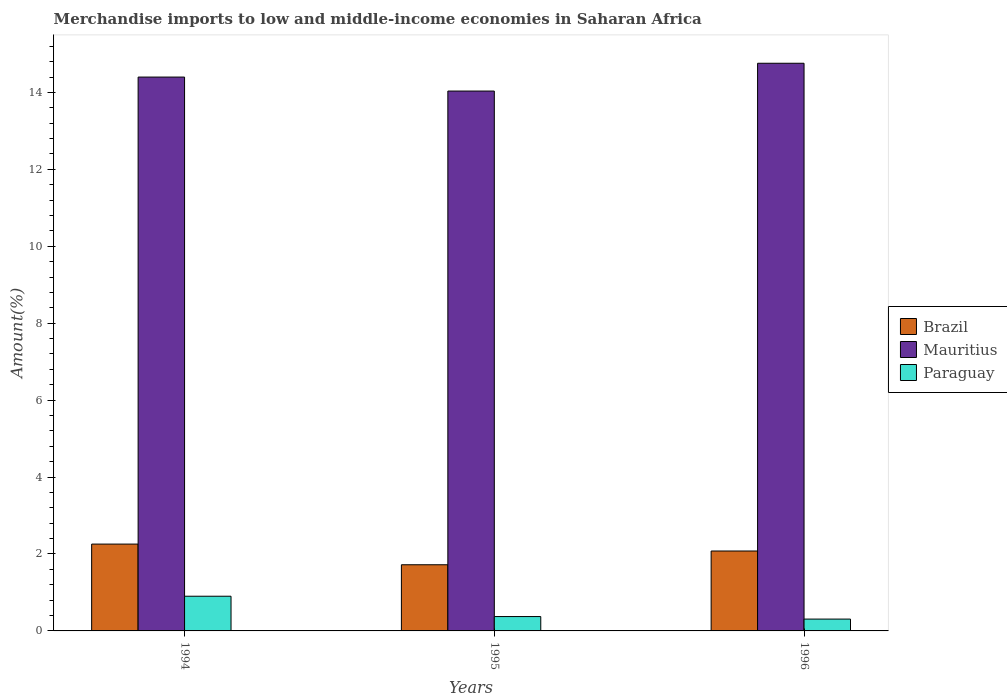Are the number of bars per tick equal to the number of legend labels?
Offer a terse response. Yes. Are the number of bars on each tick of the X-axis equal?
Keep it short and to the point. Yes. How many bars are there on the 1st tick from the left?
Your response must be concise. 3. How many bars are there on the 1st tick from the right?
Provide a short and direct response. 3. In how many cases, is the number of bars for a given year not equal to the number of legend labels?
Your response must be concise. 0. What is the percentage of amount earned from merchandise imports in Paraguay in 1994?
Provide a short and direct response. 0.9. Across all years, what is the maximum percentage of amount earned from merchandise imports in Brazil?
Provide a short and direct response. 2.26. Across all years, what is the minimum percentage of amount earned from merchandise imports in Brazil?
Offer a very short reply. 1.72. What is the total percentage of amount earned from merchandise imports in Paraguay in the graph?
Give a very brief answer. 1.58. What is the difference between the percentage of amount earned from merchandise imports in Paraguay in 1994 and that in 1996?
Offer a very short reply. 0.59. What is the difference between the percentage of amount earned from merchandise imports in Brazil in 1996 and the percentage of amount earned from merchandise imports in Paraguay in 1994?
Your answer should be compact. 1.18. What is the average percentage of amount earned from merchandise imports in Brazil per year?
Ensure brevity in your answer.  2.02. In the year 1994, what is the difference between the percentage of amount earned from merchandise imports in Brazil and percentage of amount earned from merchandise imports in Paraguay?
Ensure brevity in your answer.  1.36. In how many years, is the percentage of amount earned from merchandise imports in Brazil greater than 9.2 %?
Provide a succinct answer. 0. What is the ratio of the percentage of amount earned from merchandise imports in Paraguay in 1995 to that in 1996?
Your answer should be compact. 1.21. What is the difference between the highest and the second highest percentage of amount earned from merchandise imports in Brazil?
Keep it short and to the point. 0.18. What is the difference between the highest and the lowest percentage of amount earned from merchandise imports in Paraguay?
Provide a succinct answer. 0.59. What does the 2nd bar from the left in 1994 represents?
Provide a short and direct response. Mauritius. What does the 3rd bar from the right in 1996 represents?
Provide a short and direct response. Brazil. Are all the bars in the graph horizontal?
Give a very brief answer. No. What is the difference between two consecutive major ticks on the Y-axis?
Your answer should be compact. 2. Are the values on the major ticks of Y-axis written in scientific E-notation?
Offer a terse response. No. Does the graph contain grids?
Your answer should be very brief. No. How many legend labels are there?
Your answer should be compact. 3. What is the title of the graph?
Make the answer very short. Merchandise imports to low and middle-income economies in Saharan Africa. Does "Macao" appear as one of the legend labels in the graph?
Provide a short and direct response. No. What is the label or title of the Y-axis?
Provide a short and direct response. Amount(%). What is the Amount(%) of Brazil in 1994?
Provide a short and direct response. 2.26. What is the Amount(%) in Mauritius in 1994?
Keep it short and to the point. 14.4. What is the Amount(%) in Paraguay in 1994?
Your answer should be very brief. 0.9. What is the Amount(%) in Brazil in 1995?
Offer a terse response. 1.72. What is the Amount(%) in Mauritius in 1995?
Give a very brief answer. 14.04. What is the Amount(%) in Paraguay in 1995?
Offer a terse response. 0.37. What is the Amount(%) in Brazil in 1996?
Give a very brief answer. 2.08. What is the Amount(%) of Mauritius in 1996?
Provide a succinct answer. 14.76. What is the Amount(%) of Paraguay in 1996?
Offer a very short reply. 0.31. Across all years, what is the maximum Amount(%) of Brazil?
Your answer should be very brief. 2.26. Across all years, what is the maximum Amount(%) of Mauritius?
Your answer should be very brief. 14.76. Across all years, what is the maximum Amount(%) in Paraguay?
Offer a terse response. 0.9. Across all years, what is the minimum Amount(%) of Brazil?
Provide a short and direct response. 1.72. Across all years, what is the minimum Amount(%) in Mauritius?
Ensure brevity in your answer.  14.04. Across all years, what is the minimum Amount(%) of Paraguay?
Offer a terse response. 0.31. What is the total Amount(%) of Brazil in the graph?
Make the answer very short. 6.06. What is the total Amount(%) of Mauritius in the graph?
Ensure brevity in your answer.  43.2. What is the total Amount(%) of Paraguay in the graph?
Keep it short and to the point. 1.58. What is the difference between the Amount(%) of Brazil in 1994 and that in 1995?
Your answer should be compact. 0.54. What is the difference between the Amount(%) in Mauritius in 1994 and that in 1995?
Give a very brief answer. 0.36. What is the difference between the Amount(%) of Paraguay in 1994 and that in 1995?
Make the answer very short. 0.53. What is the difference between the Amount(%) of Brazil in 1994 and that in 1996?
Make the answer very short. 0.18. What is the difference between the Amount(%) in Mauritius in 1994 and that in 1996?
Your response must be concise. -0.36. What is the difference between the Amount(%) of Paraguay in 1994 and that in 1996?
Your answer should be compact. 0.59. What is the difference between the Amount(%) of Brazil in 1995 and that in 1996?
Ensure brevity in your answer.  -0.36. What is the difference between the Amount(%) of Mauritius in 1995 and that in 1996?
Offer a terse response. -0.72. What is the difference between the Amount(%) in Paraguay in 1995 and that in 1996?
Provide a succinct answer. 0.07. What is the difference between the Amount(%) in Brazil in 1994 and the Amount(%) in Mauritius in 1995?
Ensure brevity in your answer.  -11.78. What is the difference between the Amount(%) of Brazil in 1994 and the Amount(%) of Paraguay in 1995?
Your answer should be very brief. 1.88. What is the difference between the Amount(%) in Mauritius in 1994 and the Amount(%) in Paraguay in 1995?
Offer a very short reply. 14.03. What is the difference between the Amount(%) in Brazil in 1994 and the Amount(%) in Mauritius in 1996?
Give a very brief answer. -12.5. What is the difference between the Amount(%) in Brazil in 1994 and the Amount(%) in Paraguay in 1996?
Give a very brief answer. 1.95. What is the difference between the Amount(%) of Mauritius in 1994 and the Amount(%) of Paraguay in 1996?
Keep it short and to the point. 14.09. What is the difference between the Amount(%) in Brazil in 1995 and the Amount(%) in Mauritius in 1996?
Offer a very short reply. -13.04. What is the difference between the Amount(%) in Brazil in 1995 and the Amount(%) in Paraguay in 1996?
Offer a very short reply. 1.41. What is the difference between the Amount(%) in Mauritius in 1995 and the Amount(%) in Paraguay in 1996?
Your response must be concise. 13.73. What is the average Amount(%) of Brazil per year?
Offer a very short reply. 2.02. What is the average Amount(%) of Mauritius per year?
Ensure brevity in your answer.  14.4. What is the average Amount(%) in Paraguay per year?
Your answer should be compact. 0.53. In the year 1994, what is the difference between the Amount(%) of Brazil and Amount(%) of Mauritius?
Your response must be concise. -12.14. In the year 1994, what is the difference between the Amount(%) of Brazil and Amount(%) of Paraguay?
Offer a very short reply. 1.36. In the year 1994, what is the difference between the Amount(%) of Mauritius and Amount(%) of Paraguay?
Provide a short and direct response. 13.5. In the year 1995, what is the difference between the Amount(%) of Brazil and Amount(%) of Mauritius?
Your response must be concise. -12.32. In the year 1995, what is the difference between the Amount(%) in Brazil and Amount(%) in Paraguay?
Your answer should be very brief. 1.35. In the year 1995, what is the difference between the Amount(%) of Mauritius and Amount(%) of Paraguay?
Make the answer very short. 13.66. In the year 1996, what is the difference between the Amount(%) of Brazil and Amount(%) of Mauritius?
Provide a short and direct response. -12.68. In the year 1996, what is the difference between the Amount(%) of Brazil and Amount(%) of Paraguay?
Give a very brief answer. 1.77. In the year 1996, what is the difference between the Amount(%) of Mauritius and Amount(%) of Paraguay?
Give a very brief answer. 14.45. What is the ratio of the Amount(%) of Brazil in 1994 to that in 1995?
Ensure brevity in your answer.  1.31. What is the ratio of the Amount(%) in Mauritius in 1994 to that in 1995?
Provide a short and direct response. 1.03. What is the ratio of the Amount(%) of Paraguay in 1994 to that in 1995?
Your response must be concise. 2.42. What is the ratio of the Amount(%) in Brazil in 1994 to that in 1996?
Your answer should be compact. 1.09. What is the ratio of the Amount(%) of Mauritius in 1994 to that in 1996?
Offer a very short reply. 0.98. What is the ratio of the Amount(%) of Paraguay in 1994 to that in 1996?
Give a very brief answer. 2.93. What is the ratio of the Amount(%) in Brazil in 1995 to that in 1996?
Make the answer very short. 0.83. What is the ratio of the Amount(%) of Mauritius in 1995 to that in 1996?
Your response must be concise. 0.95. What is the ratio of the Amount(%) in Paraguay in 1995 to that in 1996?
Offer a terse response. 1.21. What is the difference between the highest and the second highest Amount(%) in Brazil?
Provide a short and direct response. 0.18. What is the difference between the highest and the second highest Amount(%) in Mauritius?
Offer a very short reply. 0.36. What is the difference between the highest and the second highest Amount(%) in Paraguay?
Make the answer very short. 0.53. What is the difference between the highest and the lowest Amount(%) in Brazil?
Provide a short and direct response. 0.54. What is the difference between the highest and the lowest Amount(%) of Mauritius?
Offer a terse response. 0.72. What is the difference between the highest and the lowest Amount(%) in Paraguay?
Offer a very short reply. 0.59. 